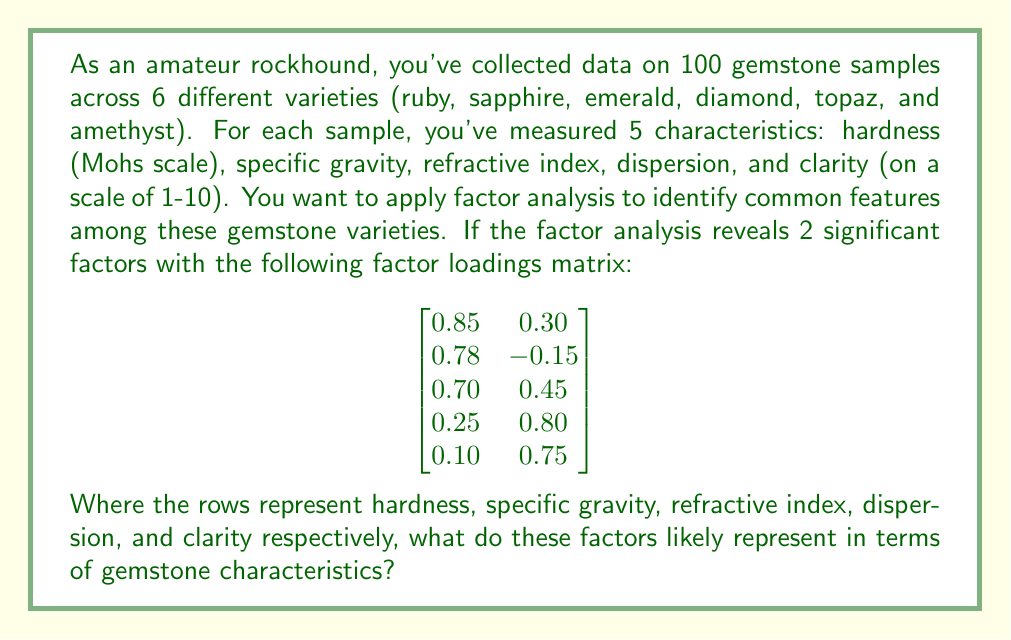What is the answer to this math problem? To interpret the results of factor analysis, we need to examine the factor loadings matrix and identify which variables have high loadings on each factor. Let's break this down step-by-step:

1. Factor 1:
   - Hardness: 0.85 (high)
   - Specific gravity: 0.78 (high)
   - Refractive index: 0.70 (high)
   - Dispersion: 0.25 (low)
   - Clarity: 0.10 (low)

2. Factor 2:
   - Hardness: 0.30 (low)
   - Specific gravity: -0.15 (very low, negative)
   - Refractive index: 0.45 (moderate)
   - Dispersion: 0.80 (high)
   - Clarity: 0.75 (high)

Interpreting these factors:

Factor 1 has high loadings on hardness, specific gravity, and refractive index. These characteristics are often related to the density and structural properties of the gemstone. Harder gemstones tend to have higher specific gravity and refractive index. This factor could represent the "physical structure" or "density-related properties" of the gemstones.

Factor 2 has high loadings on dispersion and clarity, with a moderate loading on refractive index. These characteristics are related to how light interacts with the gemstone, affecting its brilliance and visual appeal. This factor could represent the "optical properties" or "light interaction" of the gemstones.

The negative loading of specific gravity on Factor 2, although small, suggests that gemstones with high optical properties might tend to have slightly lower specific gravity, but this relationship is weak.

As an amateur rockhound, understanding these factors can help you group and classify your gemstone collection based on their underlying physical and optical properties, rather than just their individual characteristics.
Answer: Factor 1 likely represents the physical structure or density-related properties of the gemstones, while Factor 2 likely represents the optical properties or light interaction characteristics of the gemstones. 